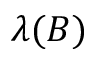<formula> <loc_0><loc_0><loc_500><loc_500>\lambda ( B )</formula> 